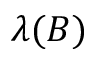<formula> <loc_0><loc_0><loc_500><loc_500>\lambda ( B )</formula> 